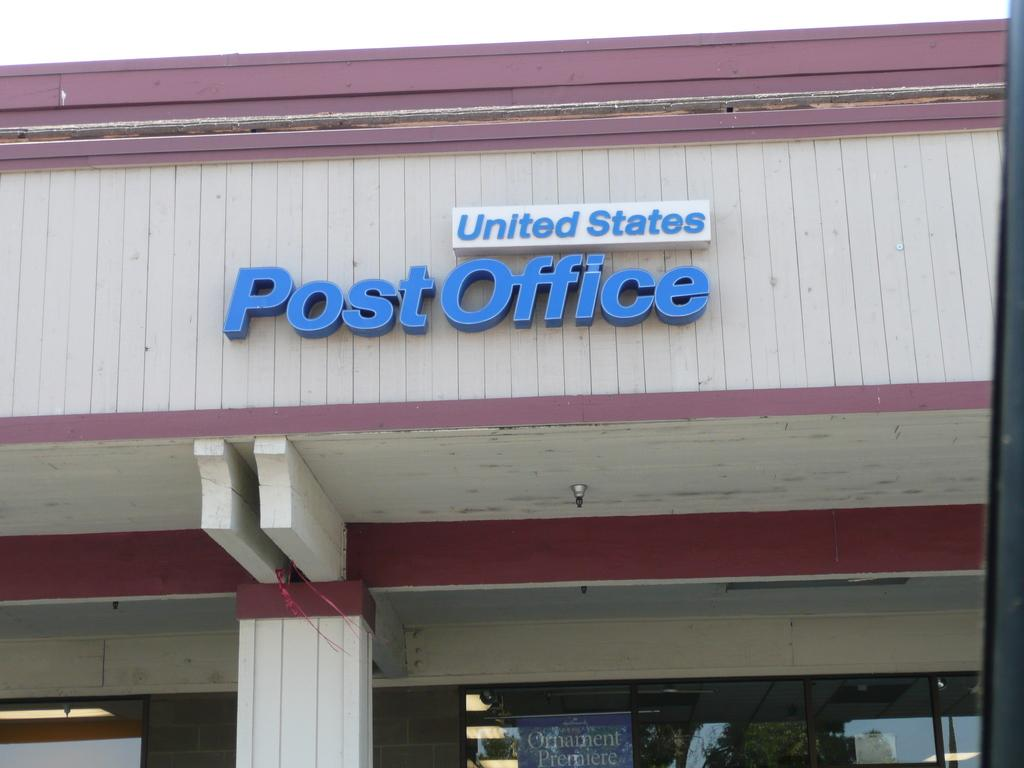What is the main object in the image? There is a name board in the image. What type of structure is depicted in the image? The image shows a structure with a roof, pillars, and a light. What is present at the bottom of the image? There is glass, a banner, lights, and a white color area at the bottom of the image. Can you see a cactus growing near the name board in the image? No, there is no cactus present in the image. Is there a dog visible in the image? No, there is no dog present in the image. 